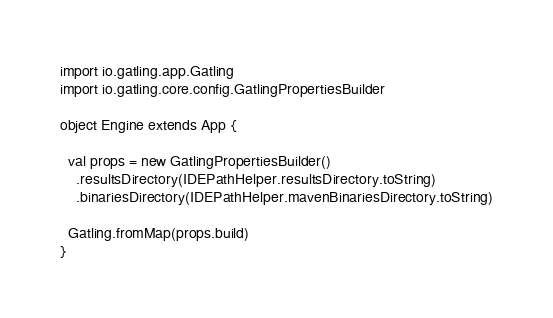Convert code to text. <code><loc_0><loc_0><loc_500><loc_500><_Scala_>import io.gatling.app.Gatling
import io.gatling.core.config.GatlingPropertiesBuilder

object Engine extends App {

  val props = new GatlingPropertiesBuilder()
    .resultsDirectory(IDEPathHelper.resultsDirectory.toString)
    .binariesDirectory(IDEPathHelper.mavenBinariesDirectory.toString)

  Gatling.fromMap(props.build)
}
</code> 